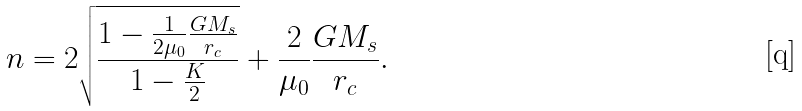Convert formula to latex. <formula><loc_0><loc_0><loc_500><loc_500>n = 2 \sqrt { \frac { 1 - \frac { 1 } { 2 \mu _ { 0 } } \frac { G M _ { s } } { r _ { c } } } { 1 - \frac { K } { 2 } } } + \frac { 2 } { \mu _ { 0 } } \frac { G M _ { s } } { r _ { c } } .</formula> 